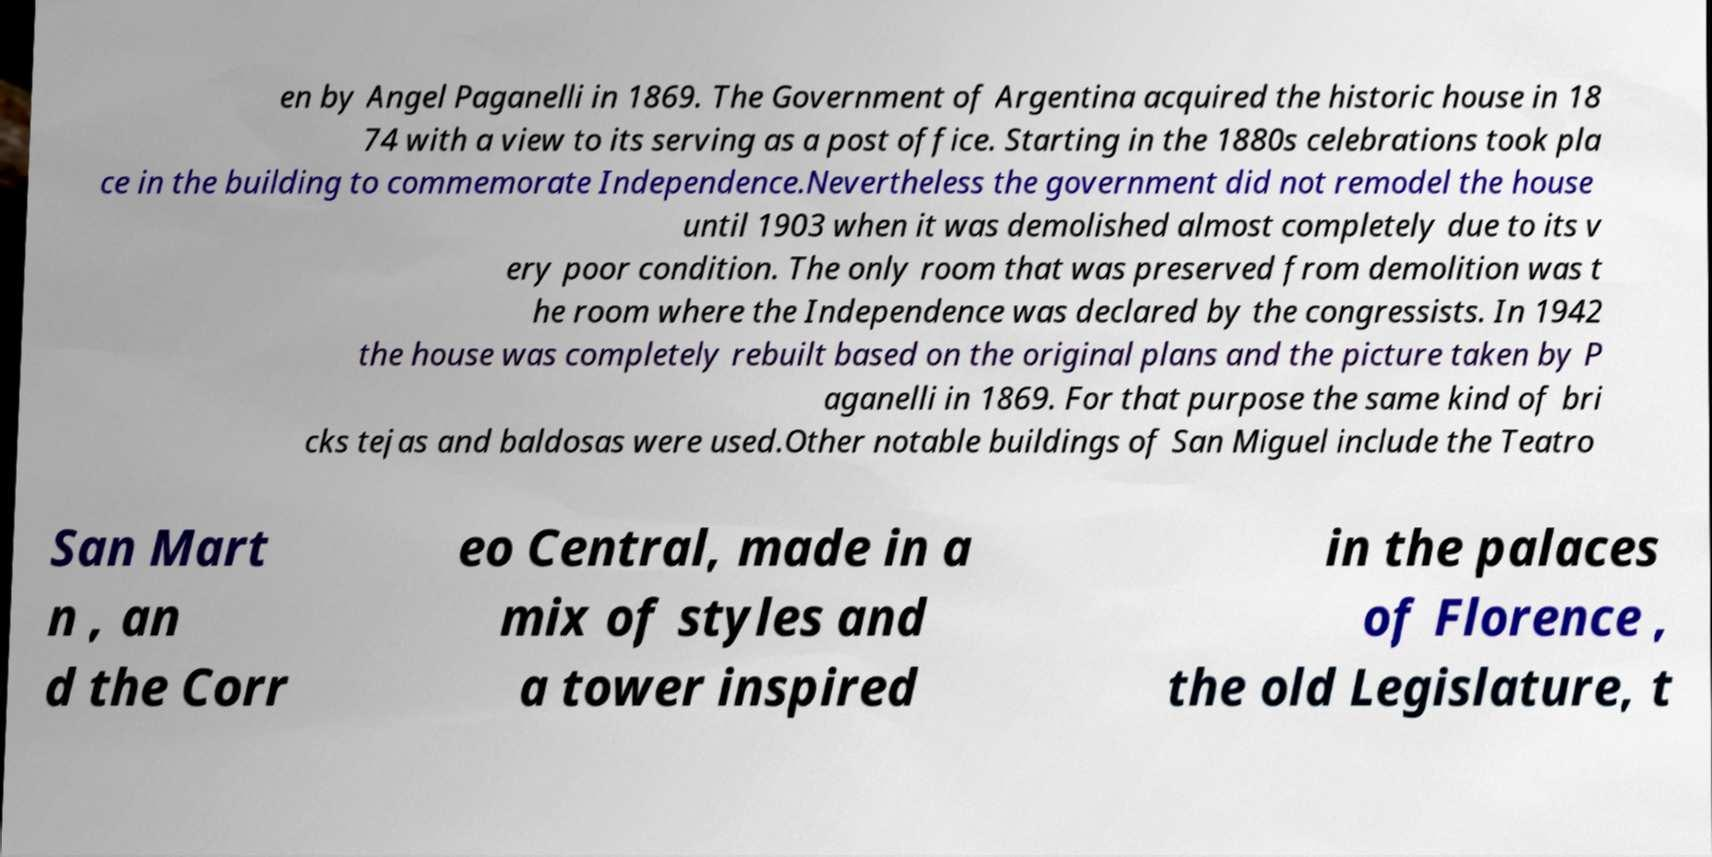Could you assist in decoding the text presented in this image and type it out clearly? en by Angel Paganelli in 1869. The Government of Argentina acquired the historic house in 18 74 with a view to its serving as a post office. Starting in the 1880s celebrations took pla ce in the building to commemorate Independence.Nevertheless the government did not remodel the house until 1903 when it was demolished almost completely due to its v ery poor condition. The only room that was preserved from demolition was t he room where the Independence was declared by the congressists. In 1942 the house was completely rebuilt based on the original plans and the picture taken by P aganelli in 1869. For that purpose the same kind of bri cks tejas and baldosas were used.Other notable buildings of San Miguel include the Teatro San Mart n , an d the Corr eo Central, made in a mix of styles and a tower inspired in the palaces of Florence , the old Legislature, t 